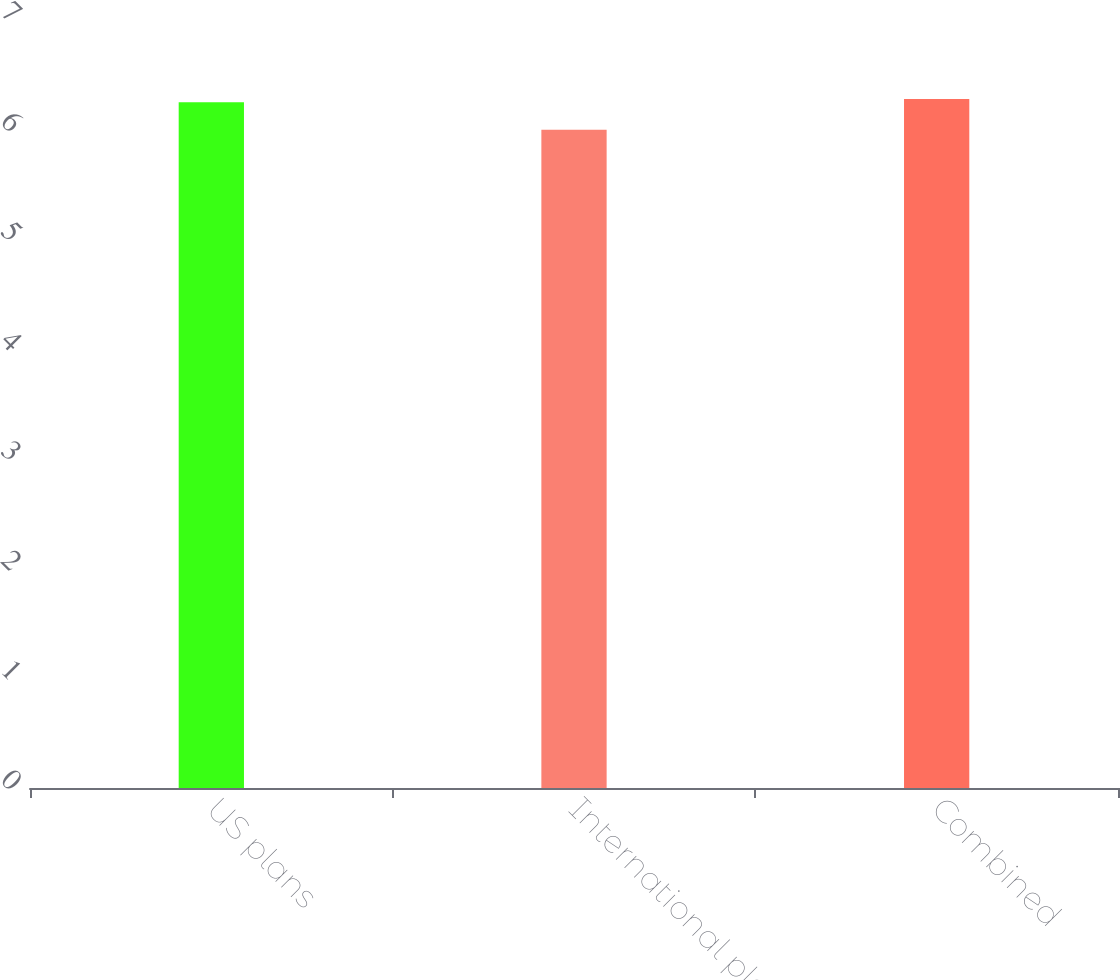Convert chart. <chart><loc_0><loc_0><loc_500><loc_500><bar_chart><fcel>US plans<fcel>International plans<fcel>Combined<nl><fcel>6.25<fcel>6<fcel>6.28<nl></chart> 